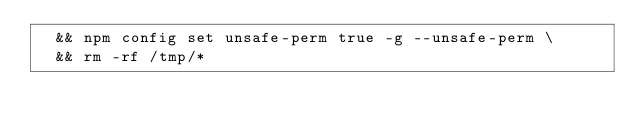<code> <loc_0><loc_0><loc_500><loc_500><_Dockerfile_>	&& npm config set unsafe-perm true -g --unsafe-perm \
	&& rm -rf /tmp/*
</code> 